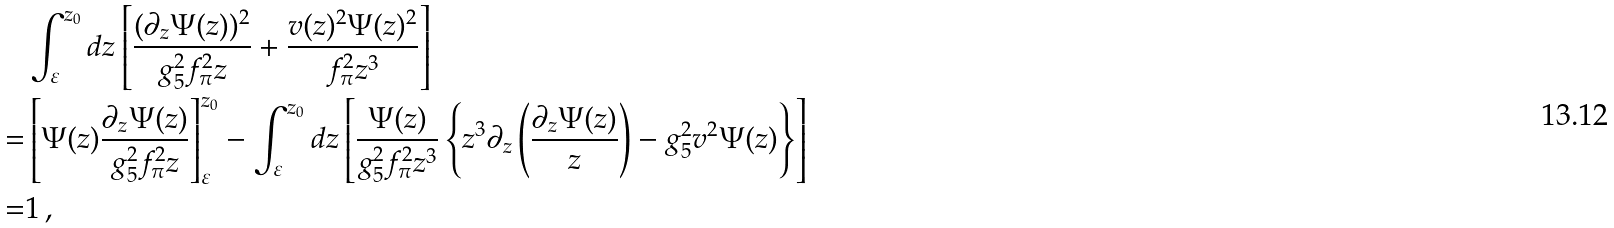<formula> <loc_0><loc_0><loc_500><loc_500>& \int _ { \varepsilon } ^ { z _ { 0 } } d z \left [ \frac { ( \partial _ { z } \Psi ( z ) ) ^ { 2 } } { g _ { 5 } ^ { 2 } f _ { \pi } ^ { 2 } z } + \frac { v ( z ) ^ { 2 } \Psi ( z ) ^ { 2 } } { f _ { \pi } ^ { 2 } z ^ { 3 } } \right ] \\ = & \left [ \Psi ( z ) \frac { \partial _ { z } \Psi ( z ) } { g _ { 5 } ^ { 2 } f _ { \pi } ^ { 2 } z } \right ] ^ { z { _ { 0 } } } _ { \varepsilon } - \int _ { \varepsilon } ^ { z _ { 0 } } d z \left [ \frac { \Psi ( z ) } { g _ { 5 } ^ { 2 } f _ { \pi } ^ { 2 } z ^ { 3 } } \left \{ z ^ { 3 } \partial _ { z } \left ( \frac { \partial _ { z } \Psi ( z ) } { z } \right ) - g _ { 5 } ^ { 2 } v ^ { 2 } \Psi ( z ) \right \} \right ] \\ = & 1 \, ,</formula> 